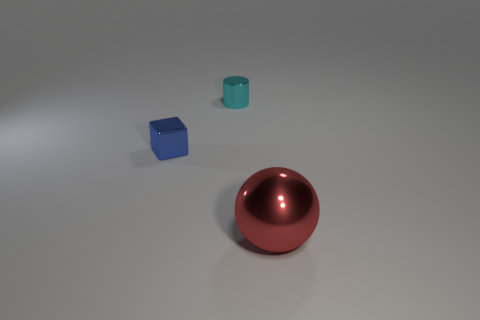What number of other things are the same size as the blue block?
Keep it short and to the point. 1. Are there any large matte objects?
Offer a terse response. No. How many tiny things are either blue metallic spheres or blue objects?
Keep it short and to the point. 1. The block has what color?
Keep it short and to the point. Blue. What shape is the small thing behind the small thing on the left side of the cyan shiny object?
Ensure brevity in your answer.  Cylinder. Are there any red spheres made of the same material as the cyan cylinder?
Offer a terse response. Yes. There is a shiny object that is behind the blue metallic block; is it the same size as the blue shiny object?
Provide a short and direct response. Yes. What number of blue objects are small objects or small blocks?
Make the answer very short. 1. What is the tiny thing behind the small blue metallic thing made of?
Keep it short and to the point. Metal. How many tiny cyan things are behind the tiny shiny thing in front of the small cylinder?
Give a very brief answer. 1. 